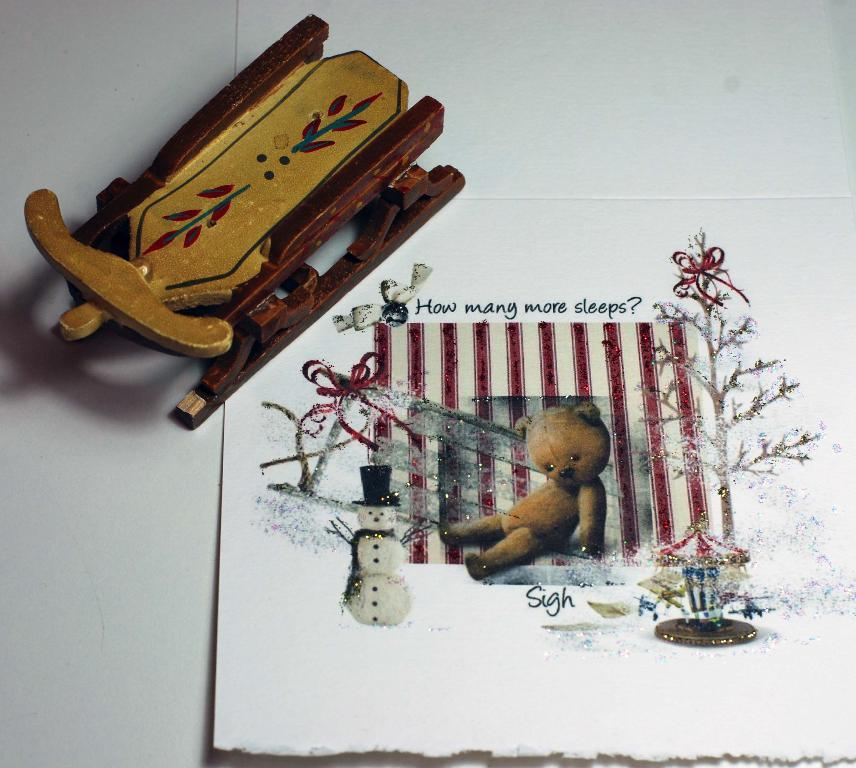What is present on the paper in the image? The facts do not specify any details about the paper in the image. Can you describe the object in the image? The facts only mention that there is an object in the image, but do not provide any details about its appearance or characteristics. What type of reaction can be seen from the fang in the image? There is no mention of a fang or any reaction in the image, as the facts only mention a paper and an object. 